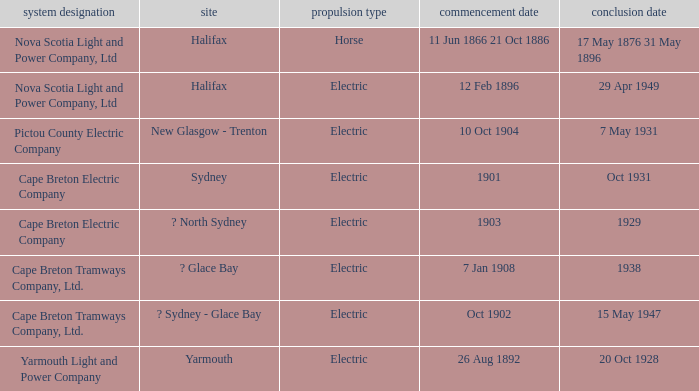What is the date (to) associated wiht a traction type of electric and the Yarmouth Light and Power Company system? 20 Oct 1928. 